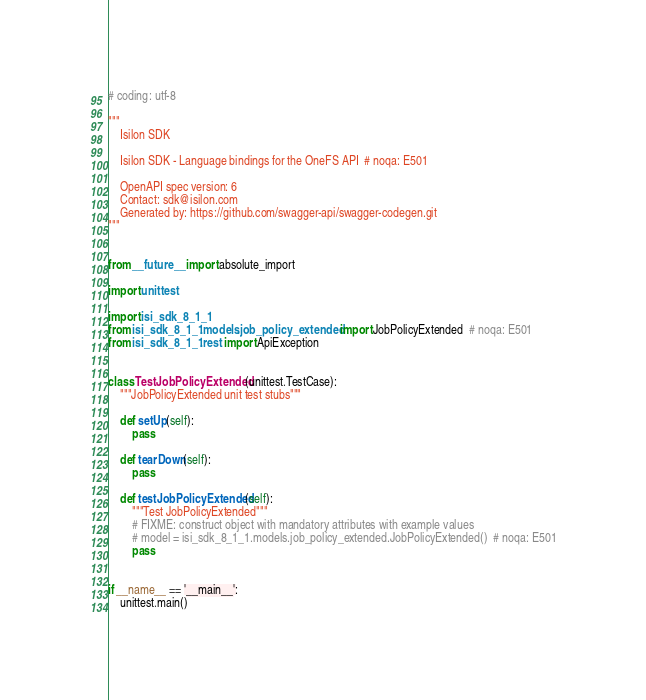Convert code to text. <code><loc_0><loc_0><loc_500><loc_500><_Python_># coding: utf-8

"""
    Isilon SDK

    Isilon SDK - Language bindings for the OneFS API  # noqa: E501

    OpenAPI spec version: 6
    Contact: sdk@isilon.com
    Generated by: https://github.com/swagger-api/swagger-codegen.git
"""


from __future__ import absolute_import

import unittest

import isi_sdk_8_1_1
from isi_sdk_8_1_1.models.job_policy_extended import JobPolicyExtended  # noqa: E501
from isi_sdk_8_1_1.rest import ApiException


class TestJobPolicyExtended(unittest.TestCase):
    """JobPolicyExtended unit test stubs"""

    def setUp(self):
        pass

    def tearDown(self):
        pass

    def testJobPolicyExtended(self):
        """Test JobPolicyExtended"""
        # FIXME: construct object with mandatory attributes with example values
        # model = isi_sdk_8_1_1.models.job_policy_extended.JobPolicyExtended()  # noqa: E501
        pass


if __name__ == '__main__':
    unittest.main()
</code> 